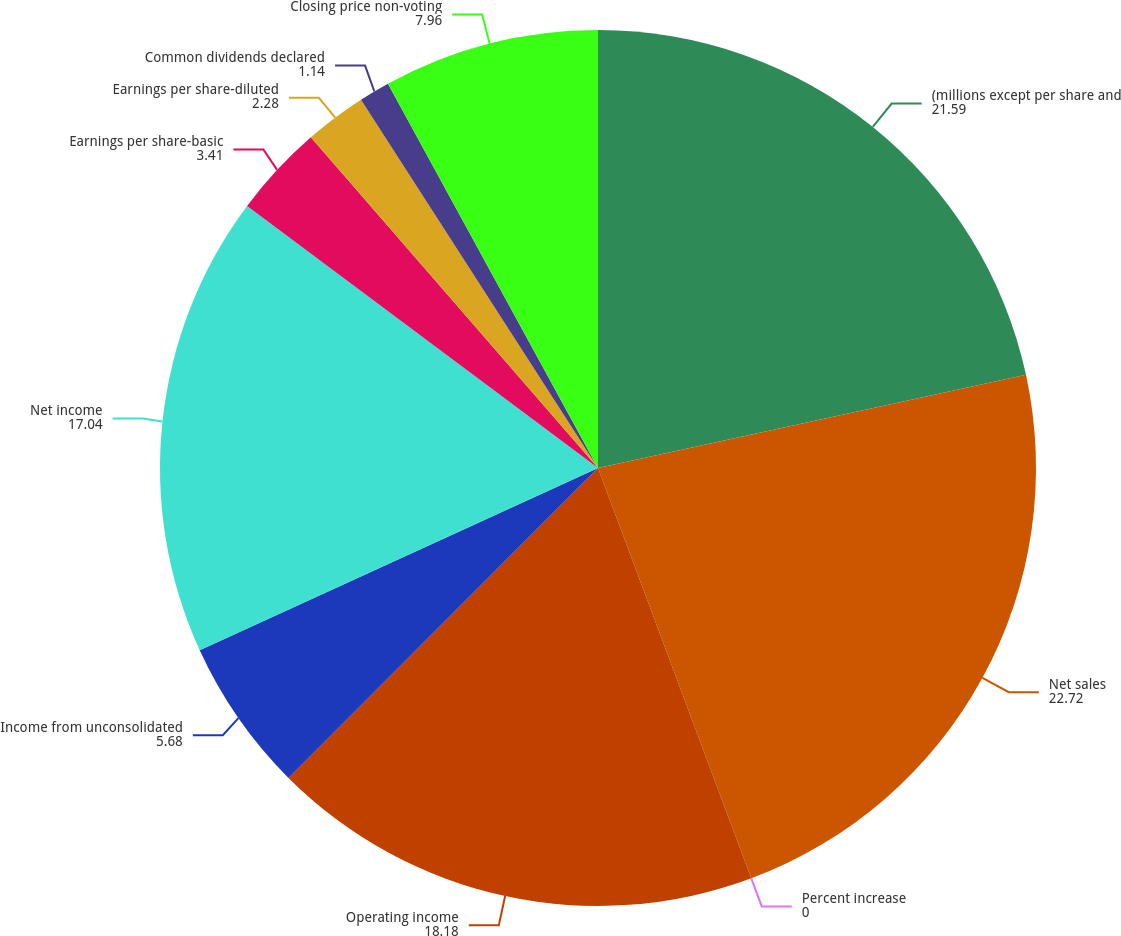<chart> <loc_0><loc_0><loc_500><loc_500><pie_chart><fcel>(millions except per share and<fcel>Net sales<fcel>Percent increase<fcel>Operating income<fcel>Income from unconsolidated<fcel>Net income<fcel>Earnings per share-basic<fcel>Earnings per share-diluted<fcel>Common dividends declared<fcel>Closing price non-voting<nl><fcel>21.59%<fcel>22.72%<fcel>0.0%<fcel>18.18%<fcel>5.68%<fcel>17.04%<fcel>3.41%<fcel>2.28%<fcel>1.14%<fcel>7.96%<nl></chart> 